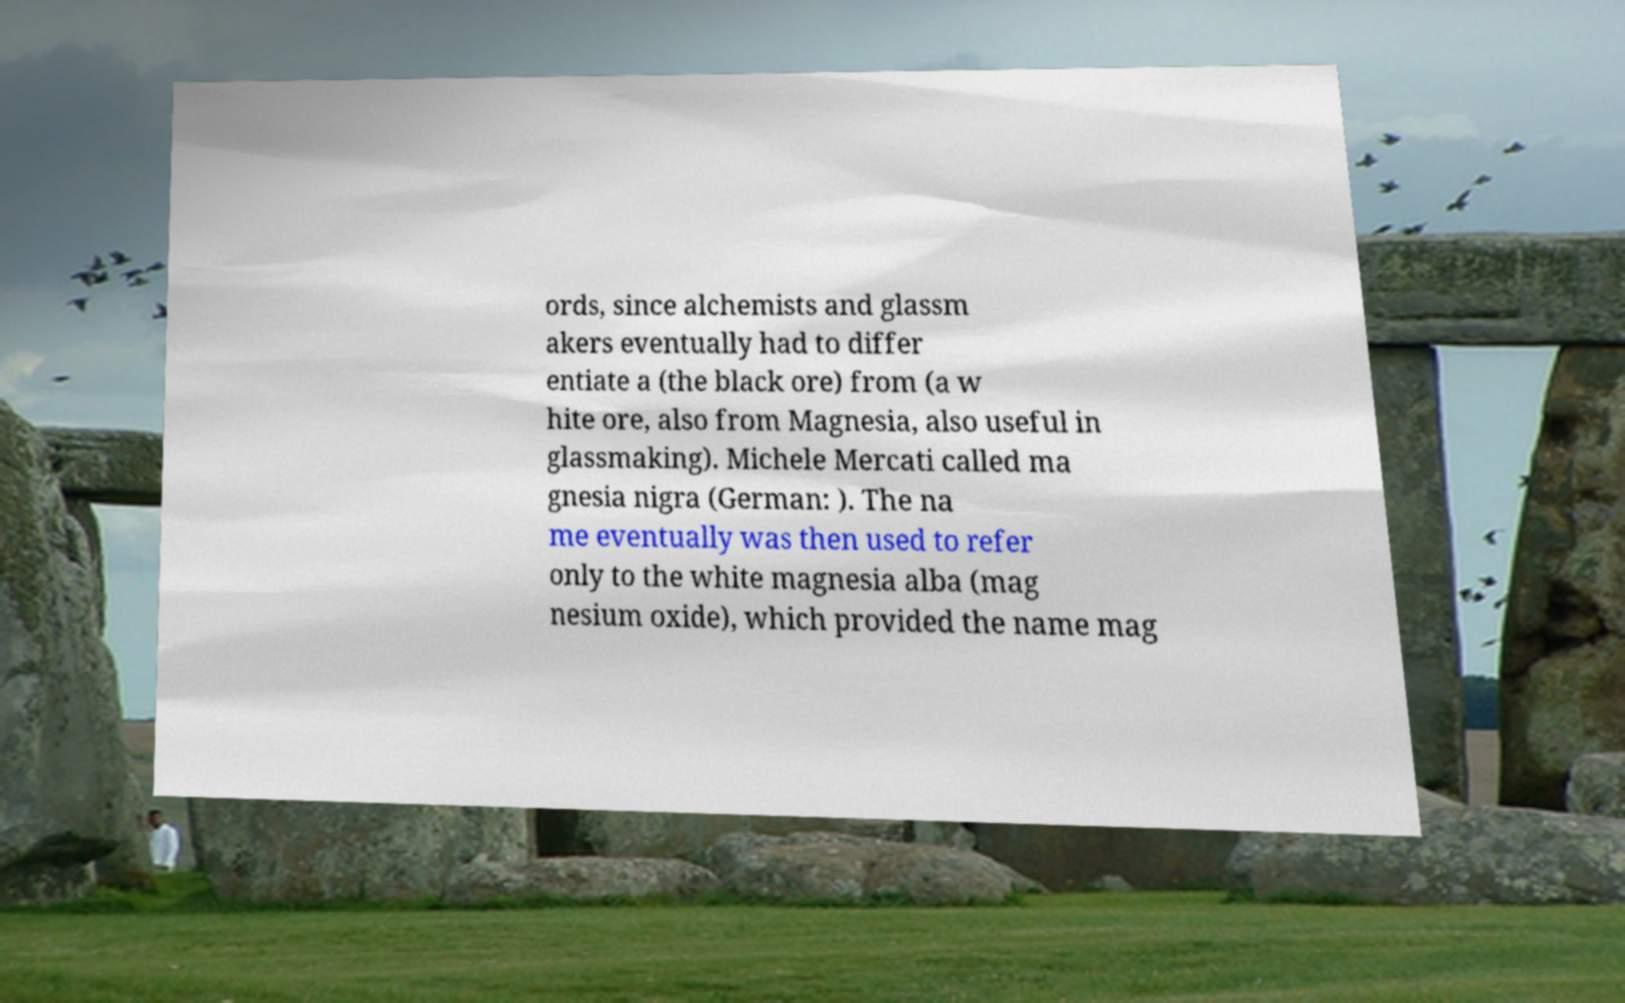Please read and relay the text visible in this image. What does it say? ords, since alchemists and glassm akers eventually had to differ entiate a (the black ore) from (a w hite ore, also from Magnesia, also useful in glassmaking). Michele Mercati called ma gnesia nigra (German: ). The na me eventually was then used to refer only to the white magnesia alba (mag nesium oxide), which provided the name mag 